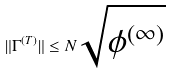<formula> <loc_0><loc_0><loc_500><loc_500>\| \Gamma ^ { ( T ) } \| \leq N \sqrt { \phi ^ { ( \infty ) } }</formula> 